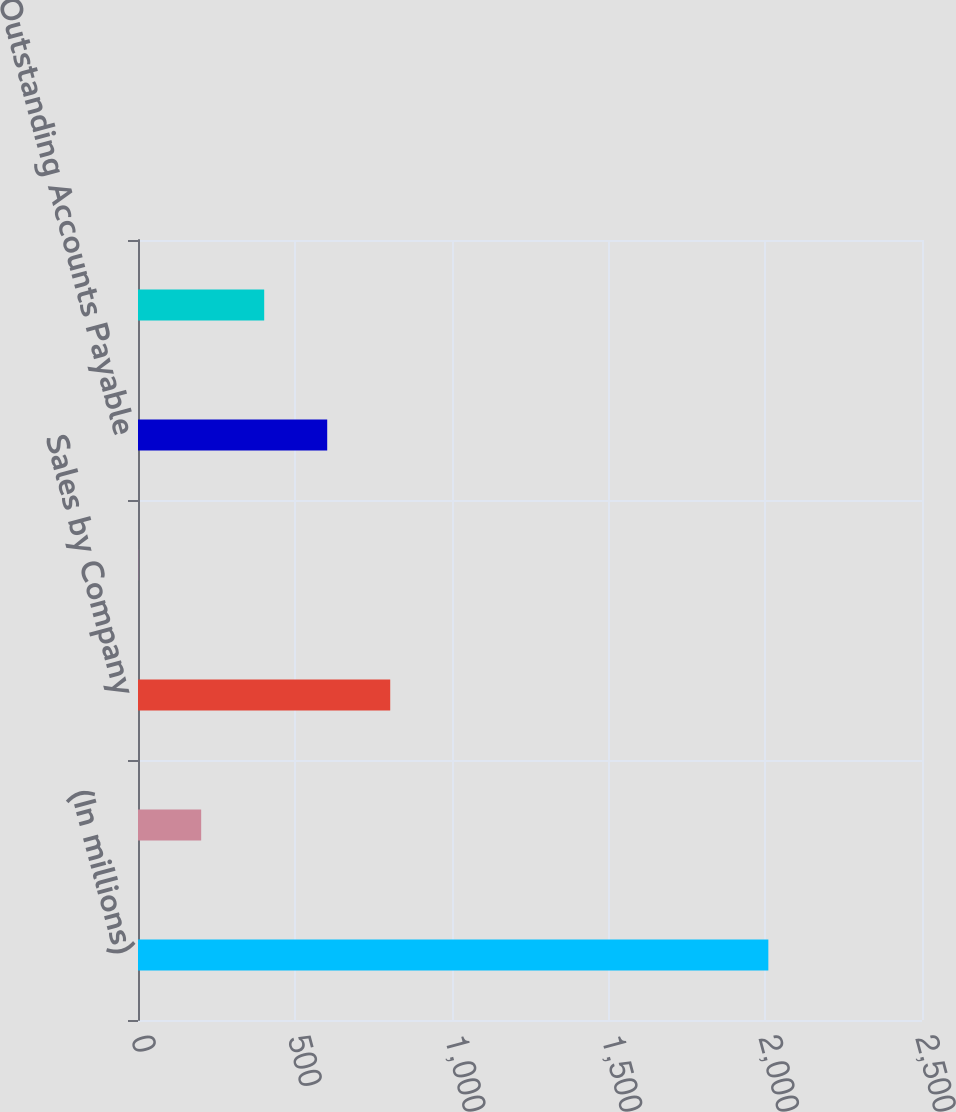<chart> <loc_0><loc_0><loc_500><loc_500><bar_chart><fcel>(In millions)<fcel>Purchases by Company<fcel>Sales by Company<fcel>Outstanding Accounts<fcel>Outstanding Accounts Payable<fcel>Administration & Management<nl><fcel>2010<fcel>201.45<fcel>804.3<fcel>0.5<fcel>603.35<fcel>402.4<nl></chart> 